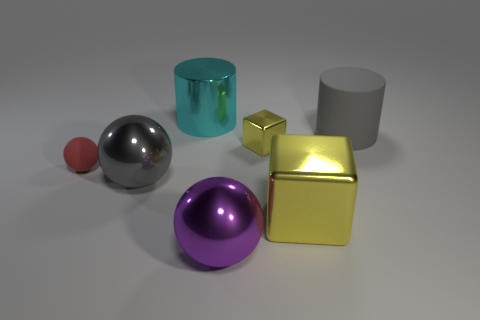How many objects are either tiny gray matte objects or yellow things that are behind the tiny sphere?
Give a very brief answer. 1. How many other things are there of the same shape as the large yellow shiny object?
Offer a terse response. 1. Are there fewer large gray objects left of the gray sphere than tiny red things that are in front of the small red thing?
Your answer should be compact. No. Is there anything else that is made of the same material as the large cyan thing?
Give a very brief answer. Yes. What shape is the tiny red object that is the same material as the gray cylinder?
Keep it short and to the point. Sphere. Are there any other things that are the same color as the big rubber cylinder?
Ensure brevity in your answer.  Yes. The big cylinder to the left of the large gray object that is on the right side of the large cyan cylinder is what color?
Keep it short and to the point. Cyan. What material is the gray object to the right of the metallic block in front of the small thing that is right of the large gray metallic sphere made of?
Make the answer very short. Rubber. How many purple shiny balls have the same size as the purple thing?
Your answer should be very brief. 0. There is a large object that is both behind the small red rubber ball and left of the gray cylinder; what is its material?
Your response must be concise. Metal. 